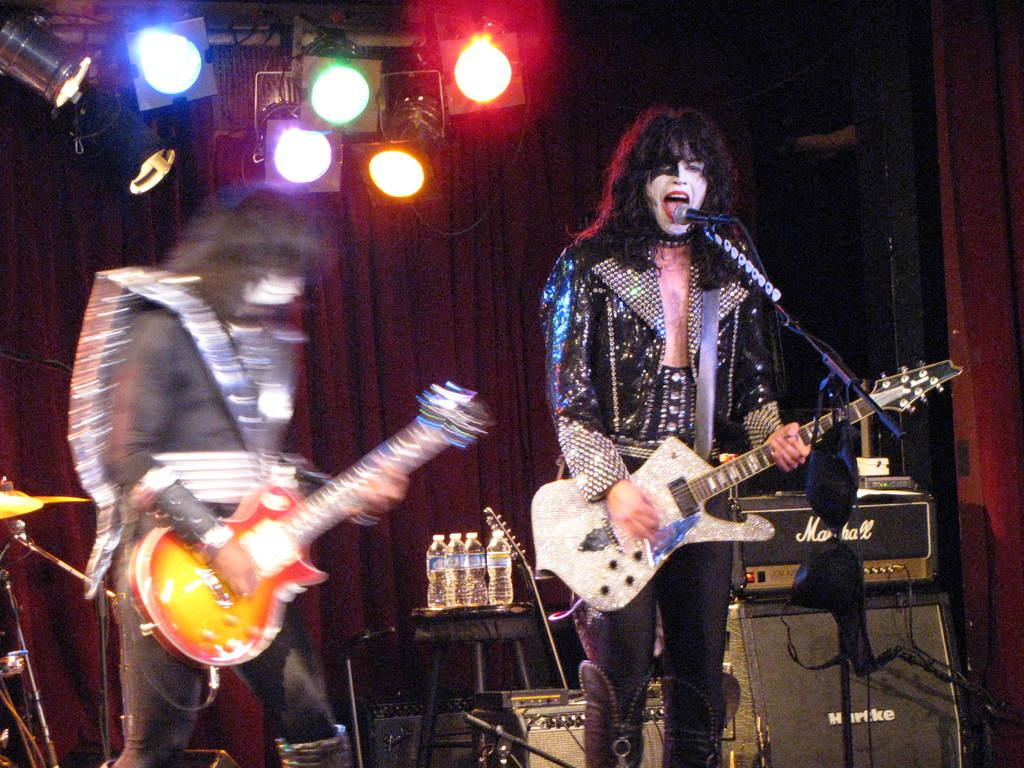How many people are in the image? There are two people in the image. What are the two people doing? The two people are playing a guitar. What object is present for amplifying sound in the image? There is a microphone (mic) in the image. What can be seen in the image that might provide illumination? There are lights in the image. What is on the table in the image? There are bottles on a table in the image. What other musical instruments can be seen in the background of the image? There are other musical instruments in the background of the image. How does the fog affect the performance in the image? There is no fog present in the image, so it does not affect the performance. What type of mark is visible on the guitar in the image? There is no mark visible on the guitar in the image. 